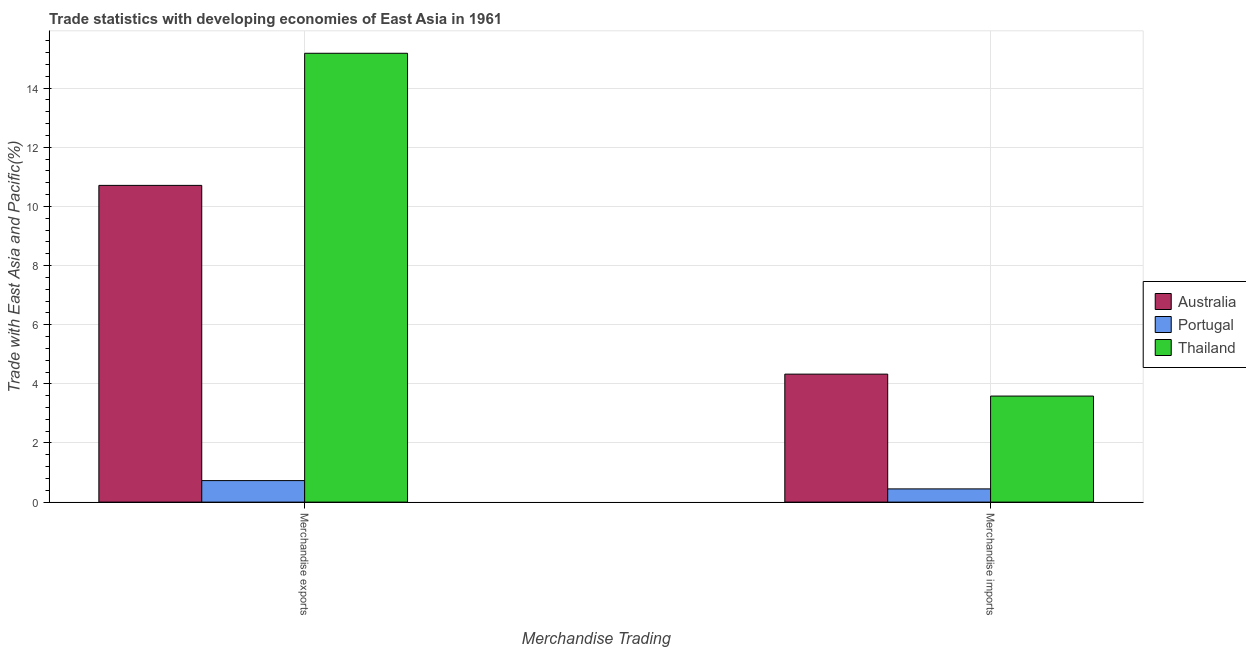How many groups of bars are there?
Give a very brief answer. 2. Are the number of bars per tick equal to the number of legend labels?
Your answer should be very brief. Yes. How many bars are there on the 1st tick from the left?
Provide a succinct answer. 3. How many bars are there on the 2nd tick from the right?
Your response must be concise. 3. What is the merchandise imports in Thailand?
Ensure brevity in your answer.  3.59. Across all countries, what is the maximum merchandise imports?
Make the answer very short. 4.33. Across all countries, what is the minimum merchandise exports?
Ensure brevity in your answer.  0.73. In which country was the merchandise exports minimum?
Your answer should be very brief. Portugal. What is the total merchandise exports in the graph?
Your response must be concise. 26.62. What is the difference between the merchandise imports in Portugal and that in Australia?
Your answer should be compact. -3.88. What is the difference between the merchandise exports in Australia and the merchandise imports in Thailand?
Make the answer very short. 7.13. What is the average merchandise imports per country?
Ensure brevity in your answer.  2.79. What is the difference between the merchandise imports and merchandise exports in Australia?
Make the answer very short. -6.38. What is the ratio of the merchandise exports in Australia to that in Thailand?
Offer a terse response. 0.71. In how many countries, is the merchandise exports greater than the average merchandise exports taken over all countries?
Provide a short and direct response. 2. What does the 3rd bar from the right in Merchandise imports represents?
Provide a succinct answer. Australia. Are all the bars in the graph horizontal?
Your answer should be very brief. No. What is the difference between two consecutive major ticks on the Y-axis?
Your response must be concise. 2. Are the values on the major ticks of Y-axis written in scientific E-notation?
Give a very brief answer. No. Does the graph contain grids?
Make the answer very short. Yes. Where does the legend appear in the graph?
Keep it short and to the point. Center right. How are the legend labels stacked?
Give a very brief answer. Vertical. What is the title of the graph?
Your response must be concise. Trade statistics with developing economies of East Asia in 1961. Does "Bangladesh" appear as one of the legend labels in the graph?
Offer a very short reply. No. What is the label or title of the X-axis?
Your answer should be very brief. Merchandise Trading. What is the label or title of the Y-axis?
Provide a short and direct response. Trade with East Asia and Pacific(%). What is the Trade with East Asia and Pacific(%) in Australia in Merchandise exports?
Make the answer very short. 10.71. What is the Trade with East Asia and Pacific(%) of Portugal in Merchandise exports?
Keep it short and to the point. 0.73. What is the Trade with East Asia and Pacific(%) of Thailand in Merchandise exports?
Offer a terse response. 15.18. What is the Trade with East Asia and Pacific(%) of Australia in Merchandise imports?
Give a very brief answer. 4.33. What is the Trade with East Asia and Pacific(%) in Portugal in Merchandise imports?
Your response must be concise. 0.45. What is the Trade with East Asia and Pacific(%) of Thailand in Merchandise imports?
Provide a succinct answer. 3.59. Across all Merchandise Trading, what is the maximum Trade with East Asia and Pacific(%) in Australia?
Your answer should be compact. 10.71. Across all Merchandise Trading, what is the maximum Trade with East Asia and Pacific(%) in Portugal?
Ensure brevity in your answer.  0.73. Across all Merchandise Trading, what is the maximum Trade with East Asia and Pacific(%) in Thailand?
Provide a short and direct response. 15.18. Across all Merchandise Trading, what is the minimum Trade with East Asia and Pacific(%) in Australia?
Keep it short and to the point. 4.33. Across all Merchandise Trading, what is the minimum Trade with East Asia and Pacific(%) of Portugal?
Offer a very short reply. 0.45. Across all Merchandise Trading, what is the minimum Trade with East Asia and Pacific(%) of Thailand?
Your response must be concise. 3.59. What is the total Trade with East Asia and Pacific(%) of Australia in the graph?
Ensure brevity in your answer.  15.04. What is the total Trade with East Asia and Pacific(%) in Portugal in the graph?
Keep it short and to the point. 1.18. What is the total Trade with East Asia and Pacific(%) in Thailand in the graph?
Your answer should be very brief. 18.77. What is the difference between the Trade with East Asia and Pacific(%) of Australia in Merchandise exports and that in Merchandise imports?
Your response must be concise. 6.38. What is the difference between the Trade with East Asia and Pacific(%) in Portugal in Merchandise exports and that in Merchandise imports?
Keep it short and to the point. 0.28. What is the difference between the Trade with East Asia and Pacific(%) of Thailand in Merchandise exports and that in Merchandise imports?
Make the answer very short. 11.59. What is the difference between the Trade with East Asia and Pacific(%) of Australia in Merchandise exports and the Trade with East Asia and Pacific(%) of Portugal in Merchandise imports?
Your response must be concise. 10.26. What is the difference between the Trade with East Asia and Pacific(%) in Australia in Merchandise exports and the Trade with East Asia and Pacific(%) in Thailand in Merchandise imports?
Offer a very short reply. 7.13. What is the difference between the Trade with East Asia and Pacific(%) of Portugal in Merchandise exports and the Trade with East Asia and Pacific(%) of Thailand in Merchandise imports?
Provide a short and direct response. -2.86. What is the average Trade with East Asia and Pacific(%) in Australia per Merchandise Trading?
Your answer should be very brief. 7.52. What is the average Trade with East Asia and Pacific(%) of Portugal per Merchandise Trading?
Offer a terse response. 0.59. What is the average Trade with East Asia and Pacific(%) of Thailand per Merchandise Trading?
Make the answer very short. 9.38. What is the difference between the Trade with East Asia and Pacific(%) of Australia and Trade with East Asia and Pacific(%) of Portugal in Merchandise exports?
Offer a terse response. 9.98. What is the difference between the Trade with East Asia and Pacific(%) of Australia and Trade with East Asia and Pacific(%) of Thailand in Merchandise exports?
Your answer should be compact. -4.47. What is the difference between the Trade with East Asia and Pacific(%) in Portugal and Trade with East Asia and Pacific(%) in Thailand in Merchandise exports?
Offer a very short reply. -14.45. What is the difference between the Trade with East Asia and Pacific(%) in Australia and Trade with East Asia and Pacific(%) in Portugal in Merchandise imports?
Give a very brief answer. 3.88. What is the difference between the Trade with East Asia and Pacific(%) of Australia and Trade with East Asia and Pacific(%) of Thailand in Merchandise imports?
Your answer should be very brief. 0.74. What is the difference between the Trade with East Asia and Pacific(%) of Portugal and Trade with East Asia and Pacific(%) of Thailand in Merchandise imports?
Provide a short and direct response. -3.14. What is the ratio of the Trade with East Asia and Pacific(%) of Australia in Merchandise exports to that in Merchandise imports?
Your response must be concise. 2.47. What is the ratio of the Trade with East Asia and Pacific(%) in Portugal in Merchandise exports to that in Merchandise imports?
Offer a terse response. 1.63. What is the ratio of the Trade with East Asia and Pacific(%) in Thailand in Merchandise exports to that in Merchandise imports?
Offer a terse response. 4.23. What is the difference between the highest and the second highest Trade with East Asia and Pacific(%) in Australia?
Your response must be concise. 6.38. What is the difference between the highest and the second highest Trade with East Asia and Pacific(%) in Portugal?
Ensure brevity in your answer.  0.28. What is the difference between the highest and the second highest Trade with East Asia and Pacific(%) in Thailand?
Your answer should be compact. 11.59. What is the difference between the highest and the lowest Trade with East Asia and Pacific(%) in Australia?
Make the answer very short. 6.38. What is the difference between the highest and the lowest Trade with East Asia and Pacific(%) in Portugal?
Offer a terse response. 0.28. What is the difference between the highest and the lowest Trade with East Asia and Pacific(%) of Thailand?
Provide a succinct answer. 11.59. 